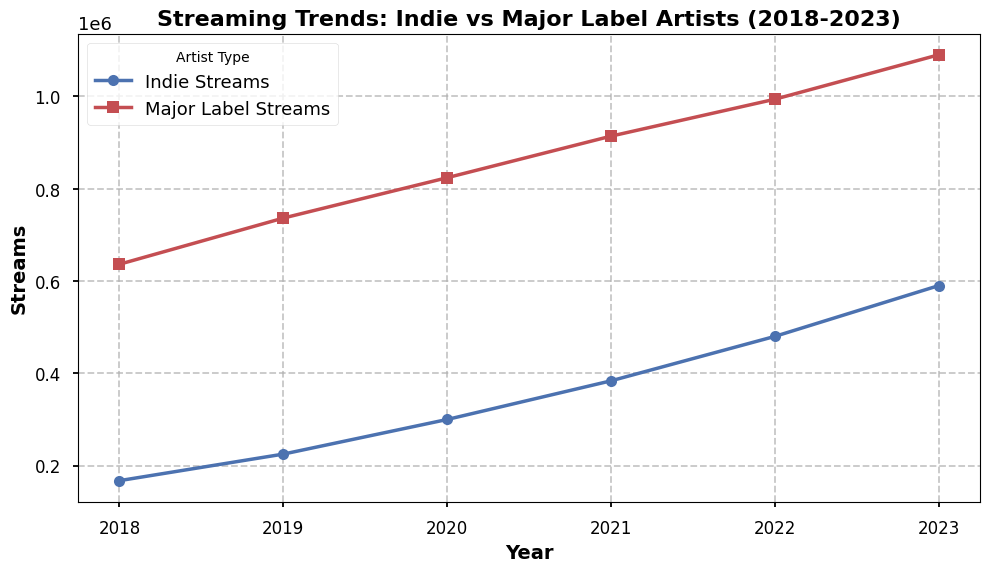How have indie artists' streaming numbers changed from 2018 to 2023? To find the change in streaming numbers, we look at the data points for indie artists in 2018 and 2023. In 2018, the highest stream count is 185,000. In 2023, the highest stream count is 620,000. The difference can be calculated as 620,000 - 185,000.
Answer: 435,000 Between 2019 and 2021, in which year did indie artists see the biggest increase in streams? To determine the year with the biggest increase, we need to compare consecutive years. In 2019, streams increased from 240,000 to 320,000 in 2020, a difference of 80,000. In 2020, streams increased from 320,000 to 410,000 in 2021, a difference of 90,000. The largest increase is therefore between 2019 and 2021.
Answer: 2021 Which type of artist had higher streams in 2020, indie or major label? By examining the plot, we can compare the values for both types of artists in 2020. For indie artists, the highest stream count is 320,000. For major label artists, the highest stream count is 850,000. Therefore, major label artists had higher streams in 2020.
Answer: Major label What is the difference in streams between indie and major label artists in 2022? To find the difference, we look at the data for 2022. The highest value for indie artists is 510,000 and for major label artists is 1,020,000. The difference is calculated as 1,020,000 - 510,000.
Answer: 510,000 In which year was the gap between indie and major label streams the smallest? To find the smallest gap, we need to compare the differences year by year. The differences in each year (highest values used) are: 
2018: 485,000 
2019: 520,000 
2020: 530,000 
2021: 530,000 
2022: 510,000 
2023: 500,000.
Thus, the smallest difference is in 2018.
Answer: 2018 In which year did major label streams exceed 1 million? By looking at the plot, we can see that major label streams exceeded 1 million in the year 2022.
Answer: 2022 What was the percentage increase in streams for indie artists from 2022 to 2023? The highest stream value for indie artists in 2022 is 510,000 and in 2023 is 620,000. The percentage increase is calculated as ((620,000 - 510,000) / 510,000) * 100. This gives us 21.57%.
Answer: 21.57% Comparing 2021 and 2023, which type of artist saw a bigger proportional increase in streams? For indie artists, the increase from 2021 (410,000) to 2023 (620,000) is 51%. For major label artists, the increase from 2021 (940,000) to 2023 (1,120,000) is 19%. Therefore, indie artists saw a bigger proportional increase in streams.
Answer: Indie artists What's the average number of streams for indie artists in 2020? Adding all the values for 2020 indie streams and dividing by 4 (the number of data points), we get an average of (280,000 + 290,000 + 310,000 + 320,000) / 4 = 300,000.
Answer: 300,000 